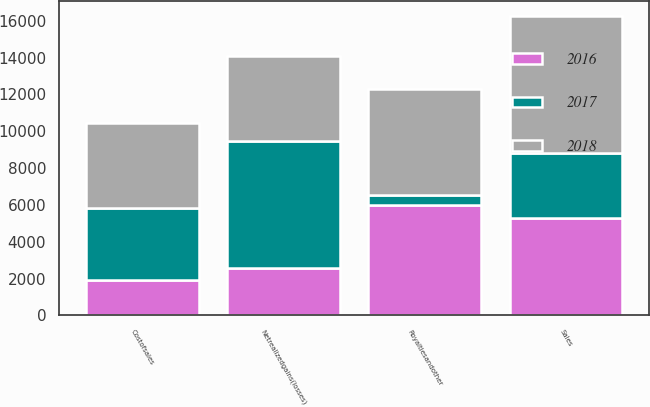Convert chart to OTSL. <chart><loc_0><loc_0><loc_500><loc_500><stacked_bar_chart><ecel><fcel>Costofsales<fcel>Sales<fcel>Royaltiesandother<fcel>Netrealizedgains(losses)<nl><fcel>2017<fcel>3909<fcel>3479<fcel>527<fcel>6861<nl><fcel>2016<fcel>1905<fcel>5315<fcel>6000<fcel>2590<nl><fcel>2018<fcel>4612<fcel>7467<fcel>5776<fcel>4612<nl></chart> 